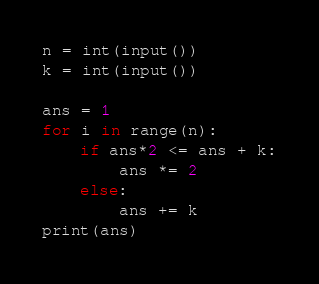<code> <loc_0><loc_0><loc_500><loc_500><_Python_>n = int(input())
k = int(input())

ans = 1
for i in range(n):
    if ans*2 <= ans + k:
        ans *= 2
    else:
        ans += k
print(ans)</code> 